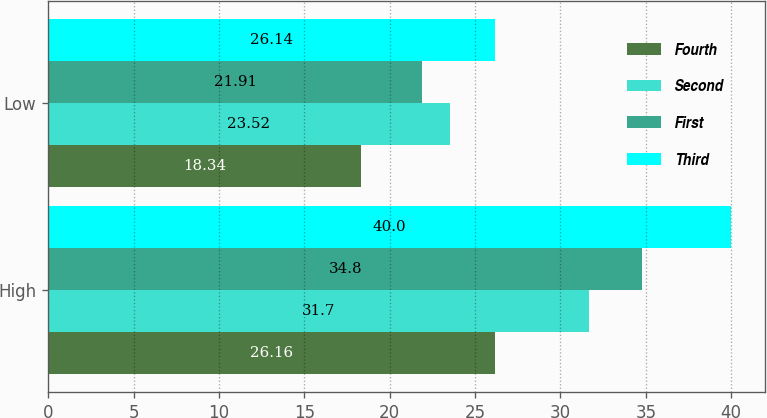Convert chart. <chart><loc_0><loc_0><loc_500><loc_500><stacked_bar_chart><ecel><fcel>High<fcel>Low<nl><fcel>Fourth<fcel>26.16<fcel>18.34<nl><fcel>Second<fcel>31.7<fcel>23.52<nl><fcel>First<fcel>34.8<fcel>21.91<nl><fcel>Third<fcel>40<fcel>26.14<nl></chart> 